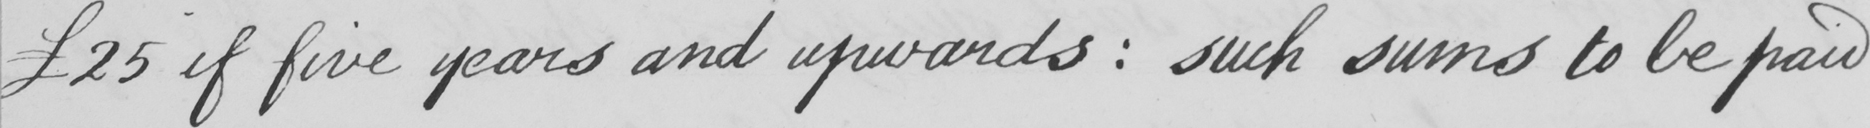Please transcribe the handwritten text in this image. £25 if five years and upwards  :  such sums to be paid 